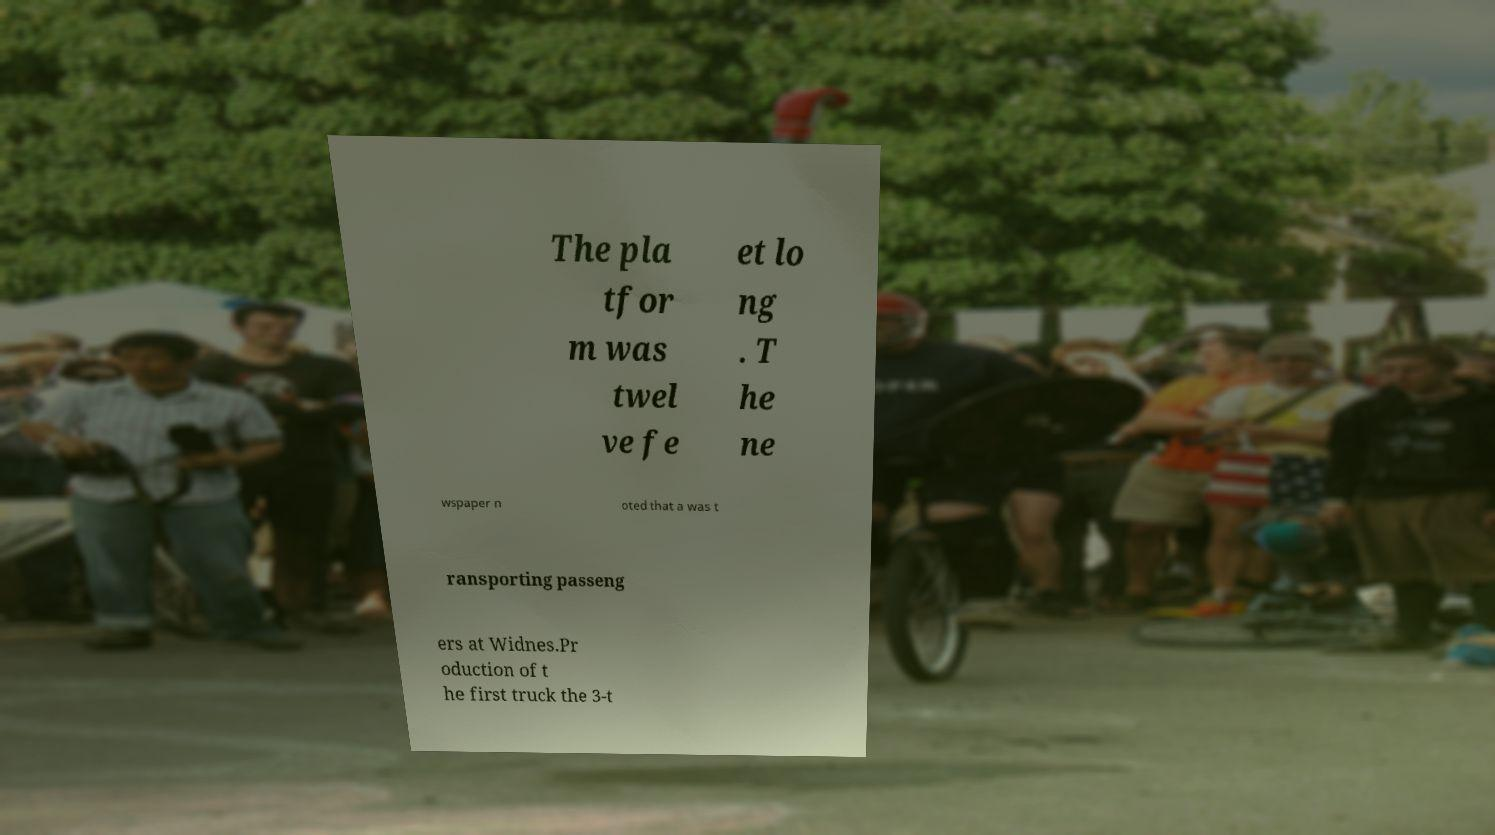Can you accurately transcribe the text from the provided image for me? The pla tfor m was twel ve fe et lo ng . T he ne wspaper n oted that a was t ransporting passeng ers at Widnes.Pr oduction of t he first truck the 3-t 